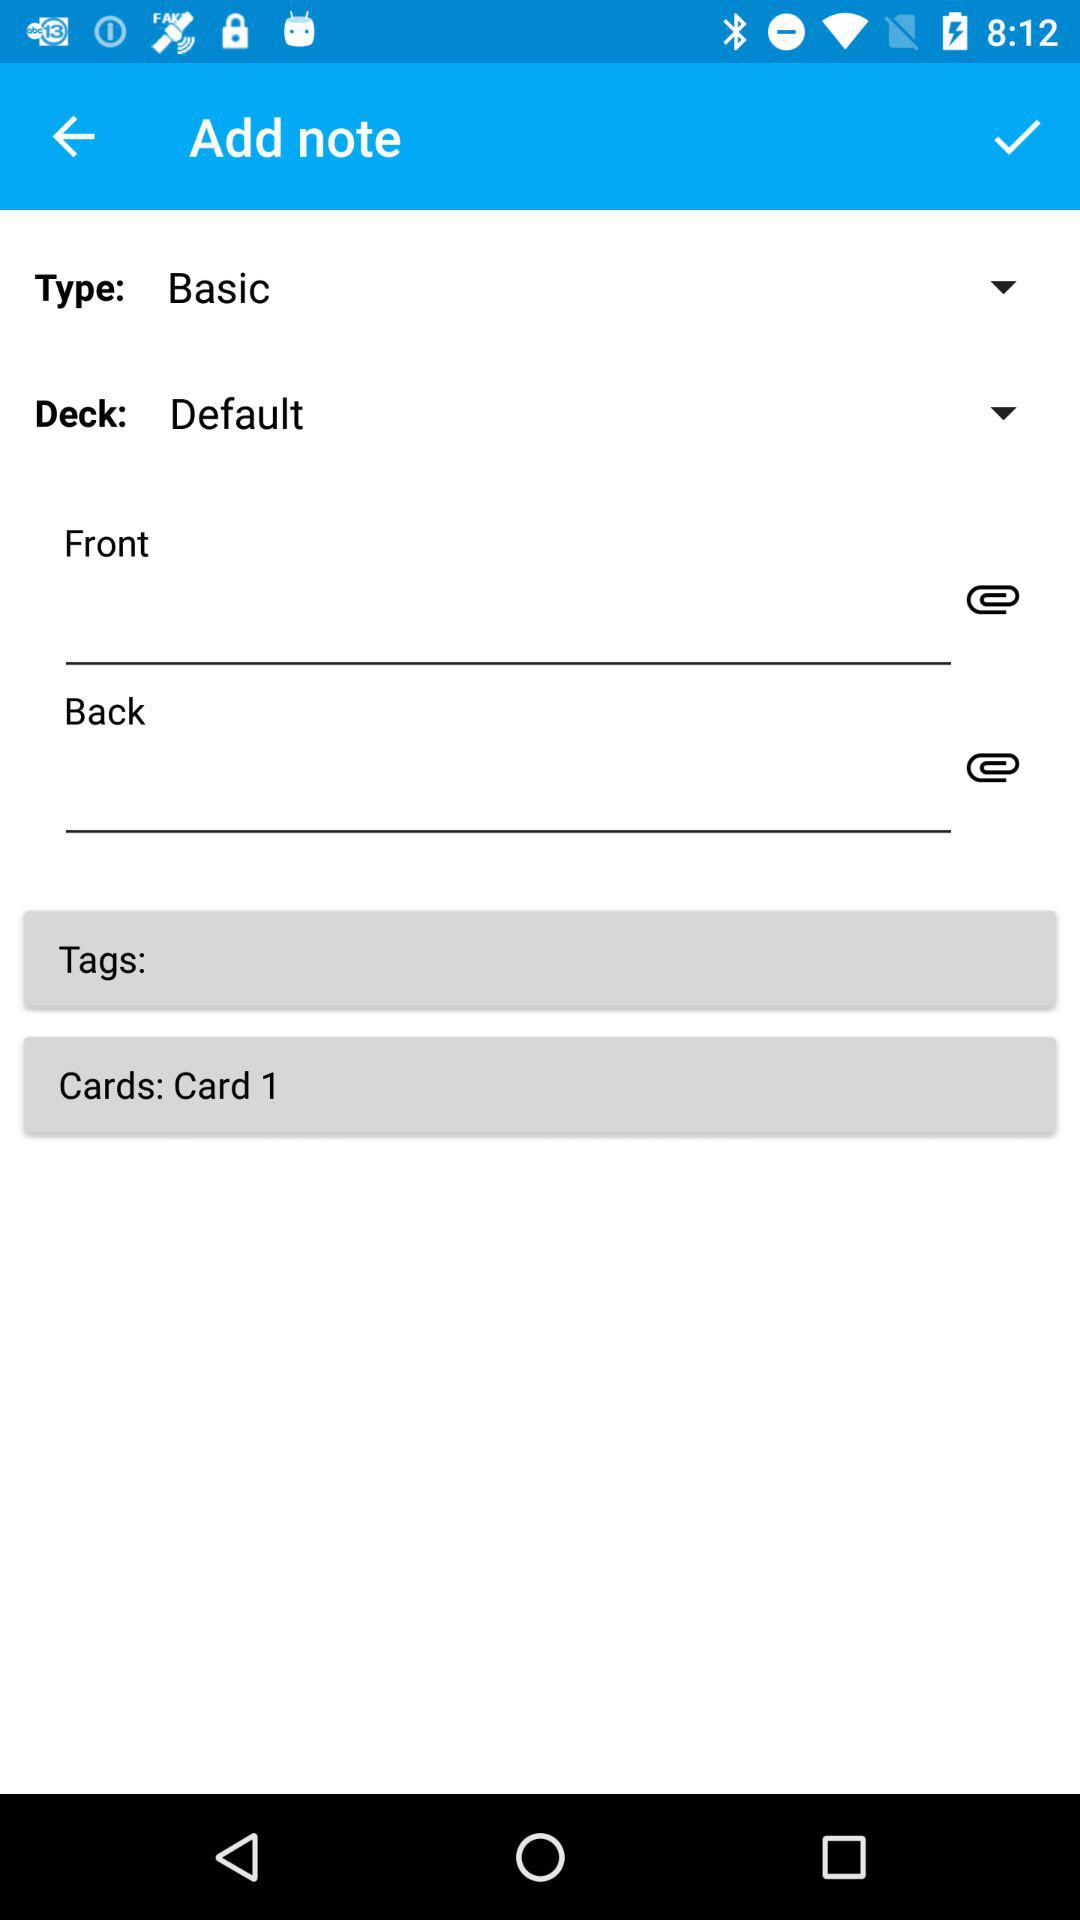What is the selected type? The selected type is "Basic". 